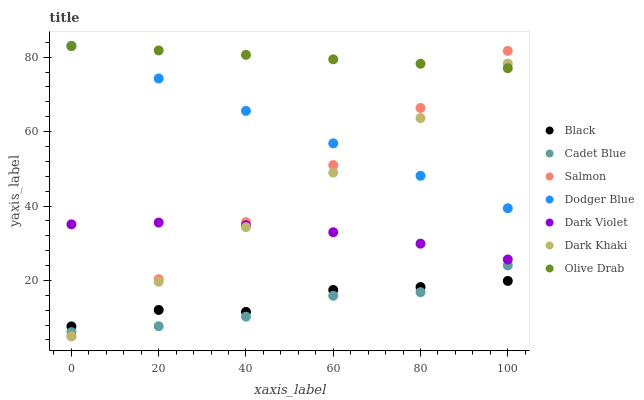Does Cadet Blue have the minimum area under the curve?
Answer yes or no. Yes. Does Olive Drab have the maximum area under the curve?
Answer yes or no. Yes. Does Salmon have the minimum area under the curve?
Answer yes or no. No. Does Salmon have the maximum area under the curve?
Answer yes or no. No. Is Dark Khaki the smoothest?
Answer yes or no. Yes. Is Black the roughest?
Answer yes or no. Yes. Is Salmon the smoothest?
Answer yes or no. No. Is Salmon the roughest?
Answer yes or no. No. Does Salmon have the lowest value?
Answer yes or no. Yes. Does Dark Violet have the lowest value?
Answer yes or no. No. Does Olive Drab have the highest value?
Answer yes or no. Yes. Does Salmon have the highest value?
Answer yes or no. No. Is Dark Violet less than Olive Drab?
Answer yes or no. Yes. Is Dark Violet greater than Black?
Answer yes or no. Yes. Does Salmon intersect Black?
Answer yes or no. Yes. Is Salmon less than Black?
Answer yes or no. No. Is Salmon greater than Black?
Answer yes or no. No. Does Dark Violet intersect Olive Drab?
Answer yes or no. No. 